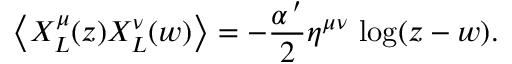Convert formula to latex. <formula><loc_0><loc_0><loc_500><loc_500>\left \langle X _ { L } ^ { \mu } ( z ) X _ { L } ^ { \nu } ( w ) \right \rangle = - \frac { \alpha ^ { \, \prime } } { 2 } \eta ^ { \mu \nu } \, \log ( z - w ) .</formula> 